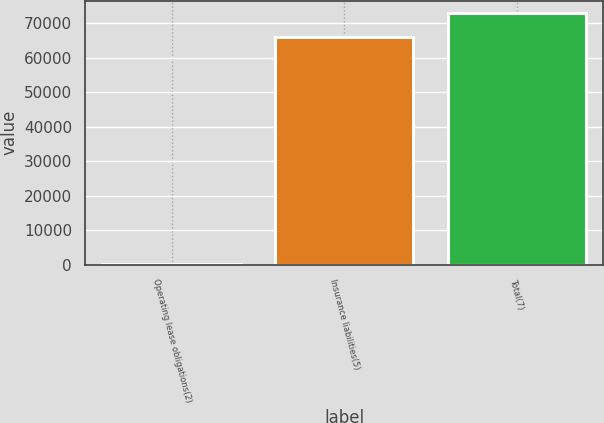Convert chart. <chart><loc_0><loc_0><loc_500><loc_500><bar_chart><fcel>Operating lease obligations(2)<fcel>Insurance liabilities(5)<fcel>Total(7)<nl><fcel>157<fcel>66127<fcel>72939.7<nl></chart> 